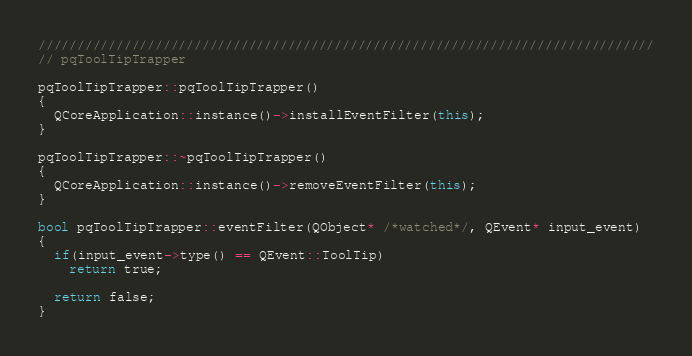Convert code to text. <code><loc_0><loc_0><loc_500><loc_500><_C++_>///////////////////////////////////////////////////////////////////////////////
// pqToolTipTrapper

pqToolTipTrapper::pqToolTipTrapper()
{
  QCoreApplication::instance()->installEventFilter(this);
}

pqToolTipTrapper::~pqToolTipTrapper()
{
  QCoreApplication::instance()->removeEventFilter(this);
}

bool pqToolTipTrapper::eventFilter(QObject* /*watched*/, QEvent* input_event)
{
  if(input_event->type() == QEvent::ToolTip)
    return true;
    
  return false;
}
</code> 